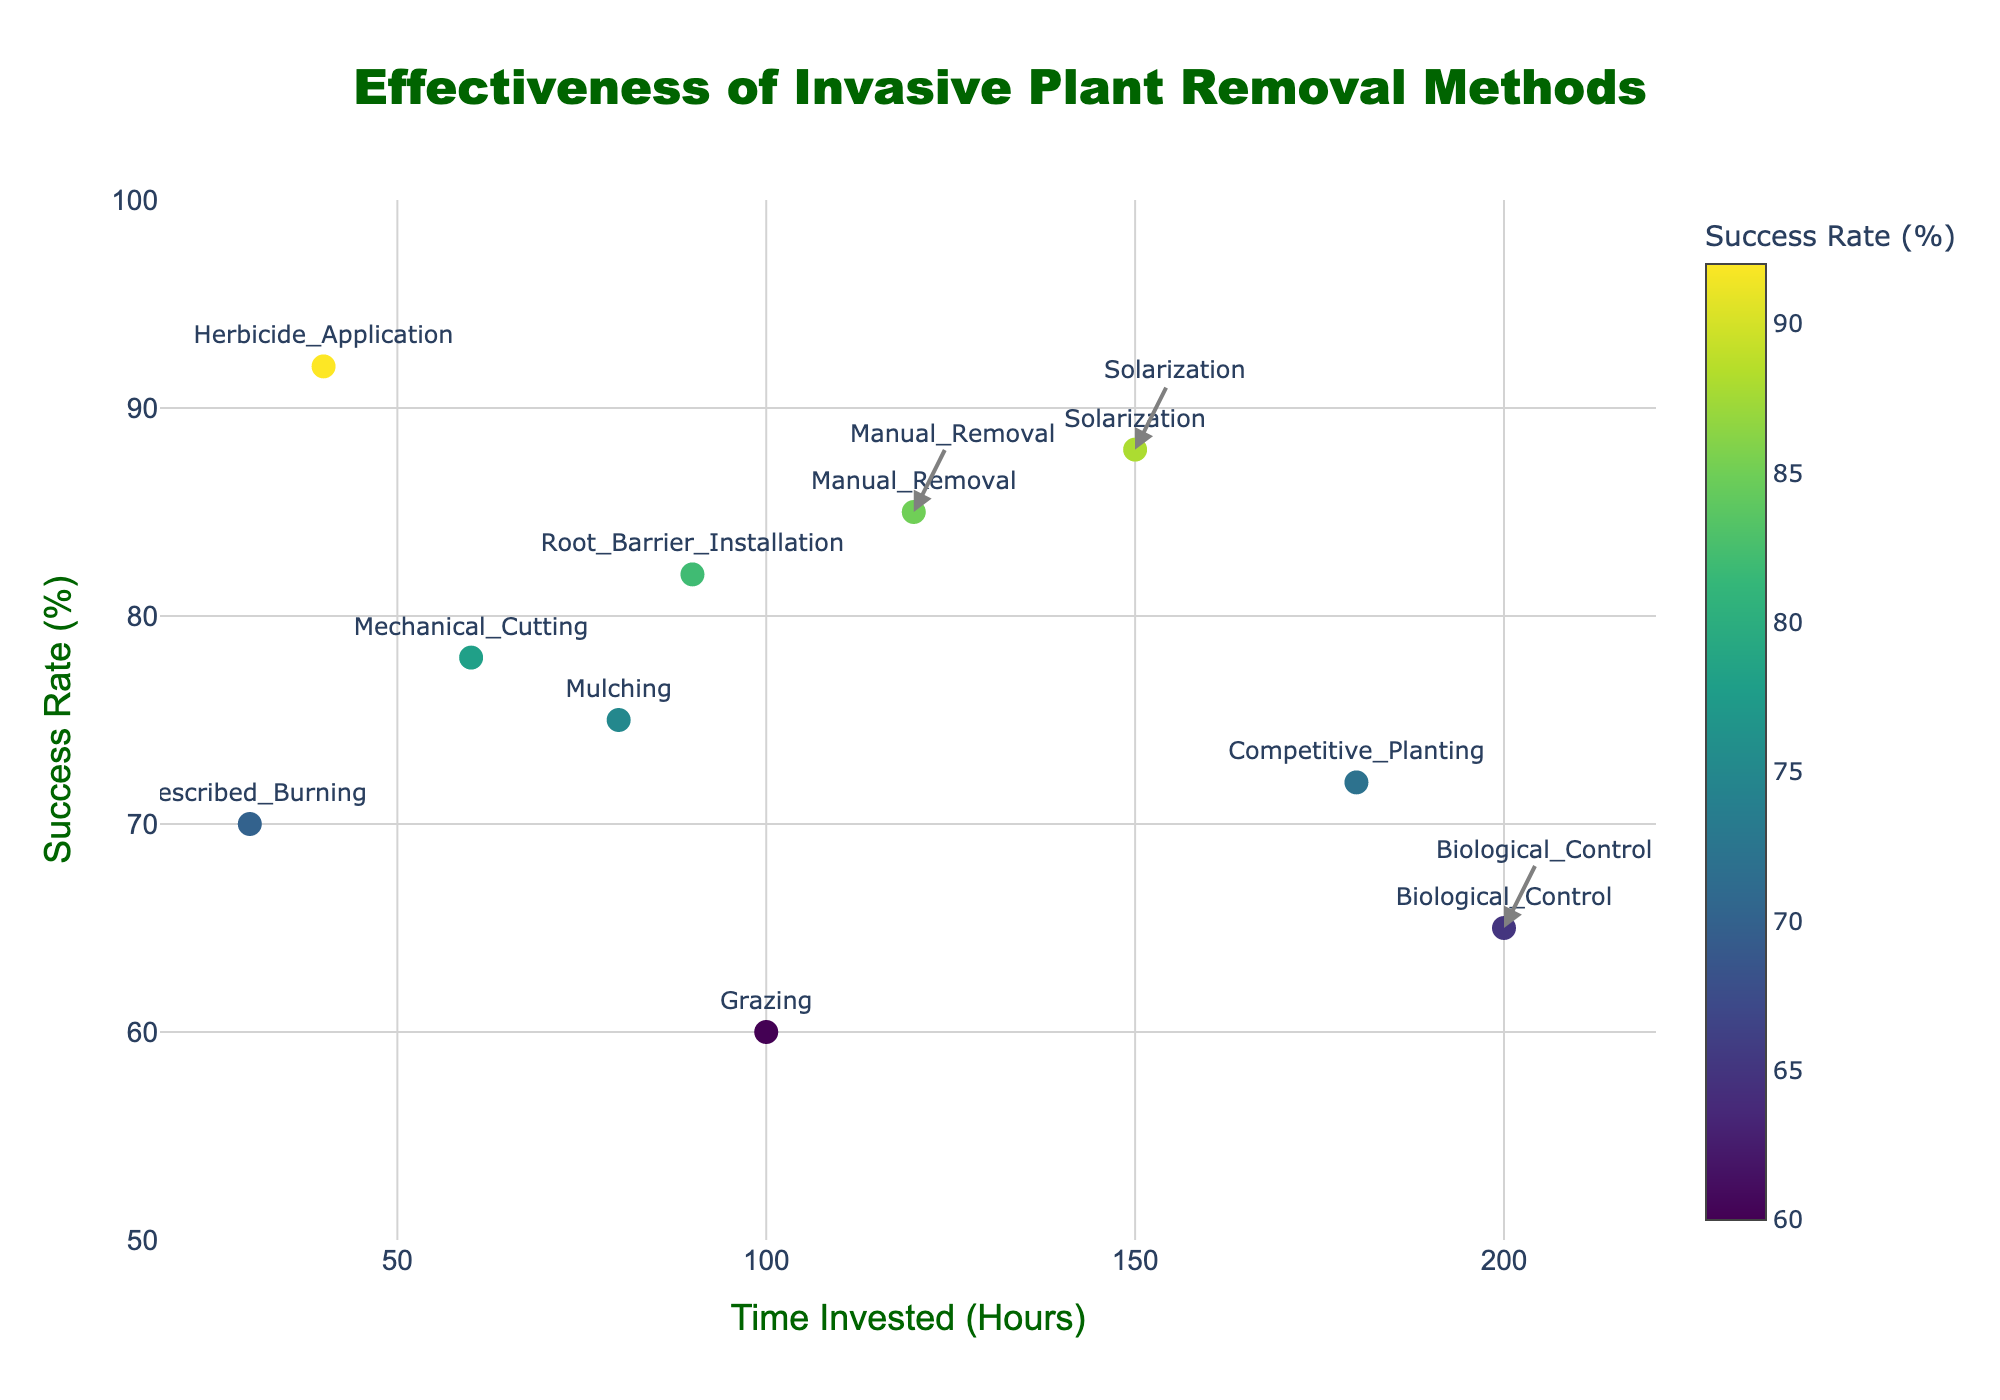How many removal methods are depicted in the figure? There are 10 data points in the scatter plot, each representing a different removal method.
Answer: 10 What is the title of the figure? The title is located at the top of the figure and reads "Effectiveness of Invasive Plant Removal Methods".
Answer: Effectiveness of Invasive Plant Removal Methods Which removal method has the highest success rate? By looking at the scatter plot, Herbicide Application has the highest success rate at 92%.
Answer: Herbicide Application Which method requires the least time invested? The method with the lowest x-coordinate is Prescribed Burning, which requires 30 hours.
Answer: Prescribed Burning What is the average success rate of all methods? Sum the success rates (85 + 92 + 78 + 70 + 65 + 88 + 75 + 60 + 72 + 82) = 767, divide by the number of methods 10: 767/10 = 76.7
Answer: 76.7 How does the success rate of Solarization compare to Manual Removal? Solarization has a success rate of 88%, which is higher than Manual Removal at 85%.
Answer: Solarization has a higher success rate Which method requires the most time invested? The method with the highest x-coordinate is Biological Control, which requires 200 hours.
Answer: Biological Control For methods investing around 60 hours, compare their success rates. Mechanical Cutting and Mulching are around 60 hours. Mechanical Cutting has a success rate of 78%, and Mulching has 75%.
Answer: Mechanical Cutting has a higher success rate What is the difference in success rate between Manual Removal and Grazing? Manual Removal has a success rate of 85%, and Grazing has 60%. The difference is 85 - 60 = 25%.
Answer: 25% Which removal method is closest to the median success rate? The median success rate is the middle value of the ordered success rates. Ordered: 60, 65, 70, 72, 75, 78, 82, 85, 88, 92. The median (average of 75 and 78) is 76.5. Mechanical Cutting is closest at 78%.
Answer: Mechanical Cutting 